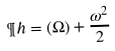<formula> <loc_0><loc_0><loc_500><loc_500>\P h = \real ( \Omega ) + \frac { \omega ^ { 2 } } { 2 }</formula> 